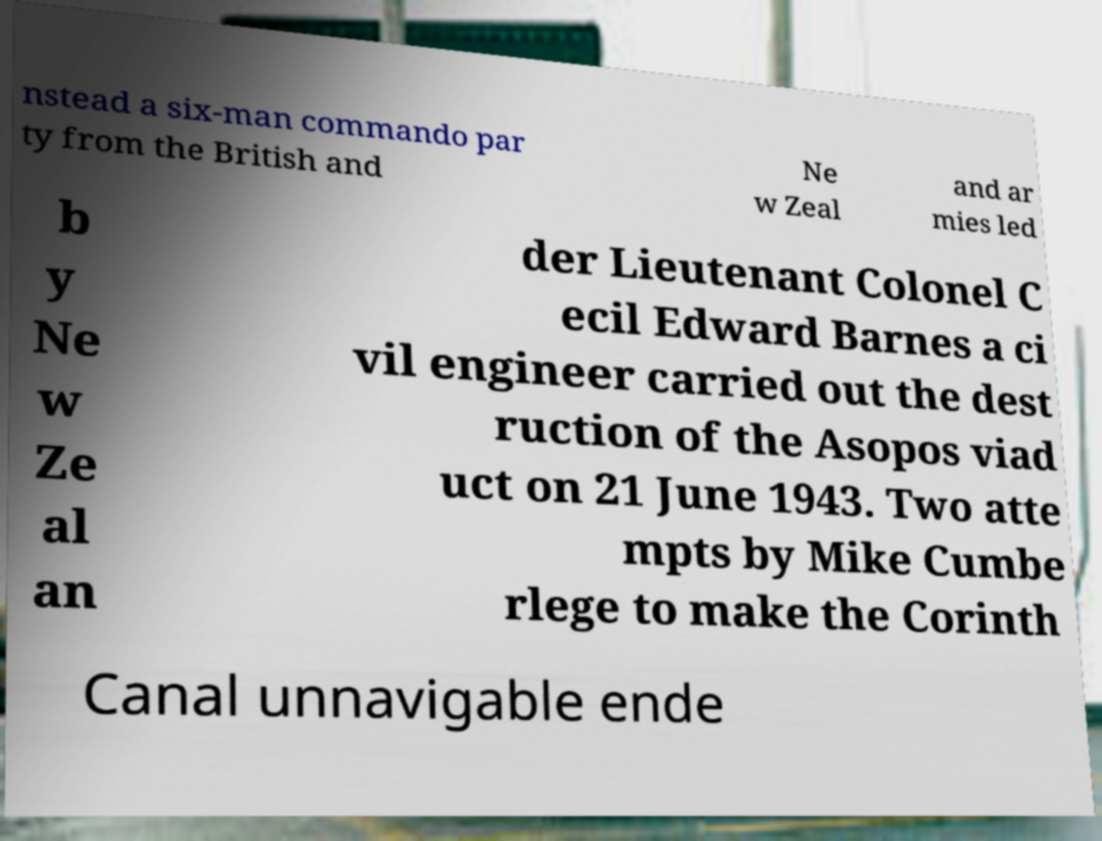Can you accurately transcribe the text from the provided image for me? nstead a six-man commando par ty from the British and Ne w Zeal and ar mies led b y Ne w Ze al an der Lieutenant Colonel C ecil Edward Barnes a ci vil engineer carried out the dest ruction of the Asopos viad uct on 21 June 1943. Two atte mpts by Mike Cumbe rlege to make the Corinth Canal unnavigable ende 